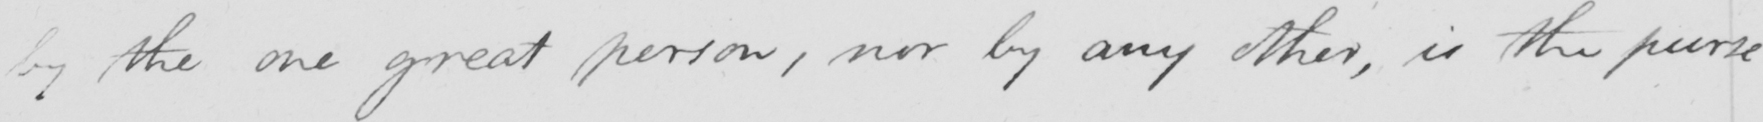What is written in this line of handwriting? by the great person, nor by any other, is the purse 